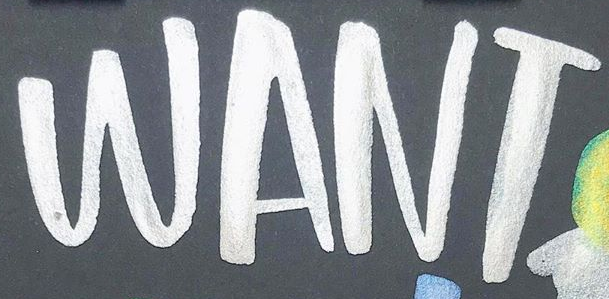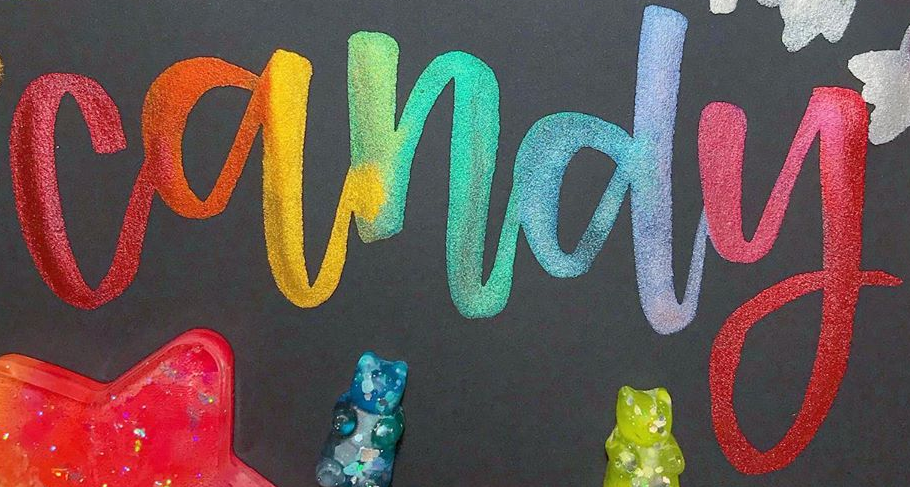What words can you see in these images in sequence, separated by a semicolon? WANT; candy 